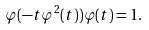Convert formula to latex. <formula><loc_0><loc_0><loc_500><loc_500>\varphi ( - t \varphi ^ { 2 } ( t ) ) \varphi ( t ) = 1 .</formula> 